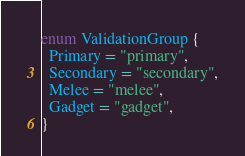Convert code to text. <code><loc_0><loc_0><loc_500><loc_500><_TypeScript_>enum ValidationGroup {
  Primary = "primary",
  Secondary = "secondary",
  Melee = "melee",
  Gadget = "gadget",
}
</code> 